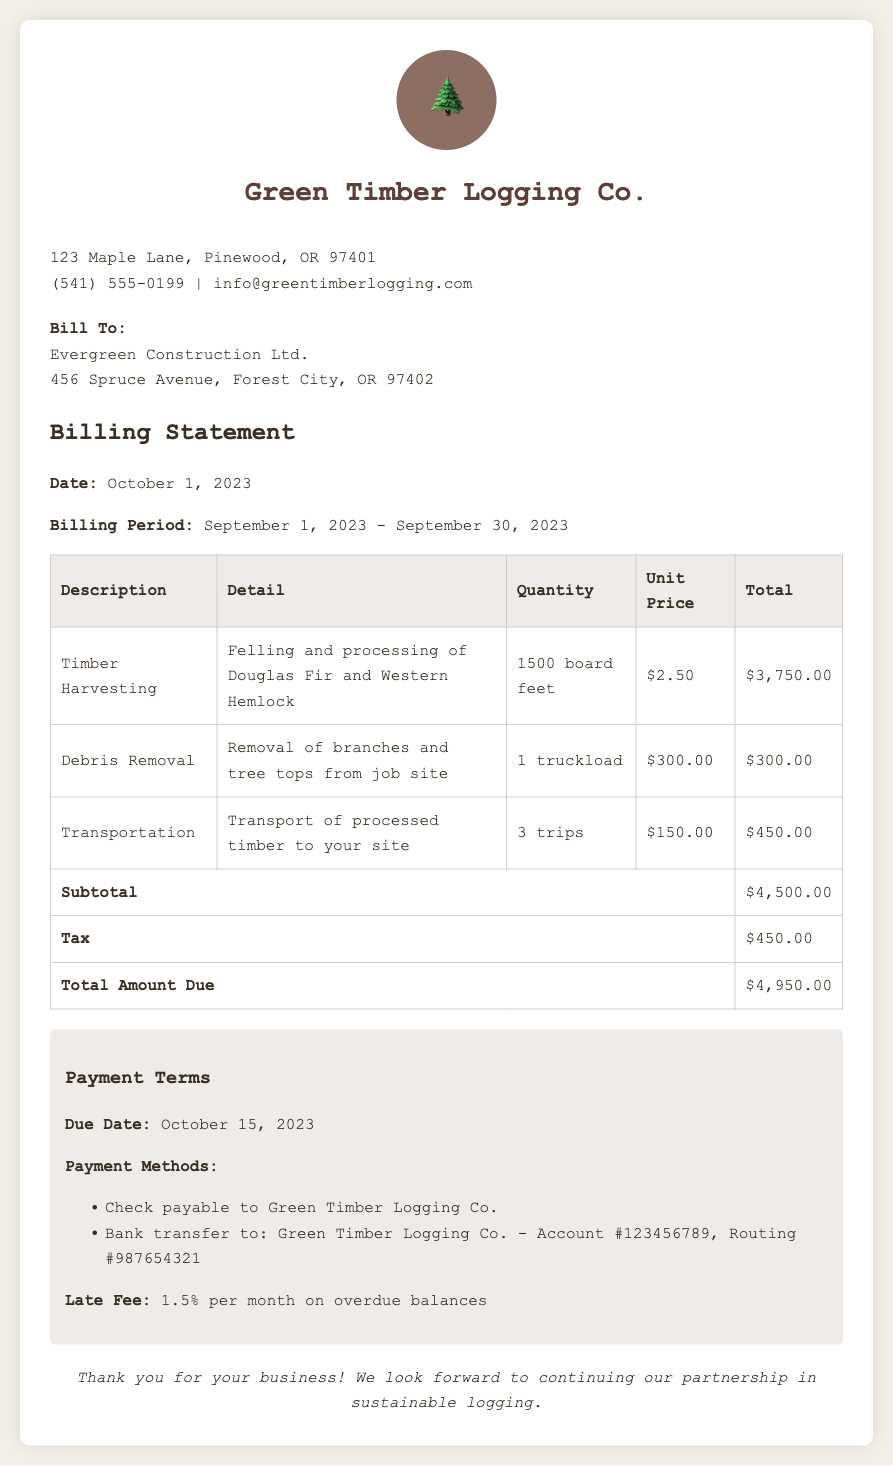What is the billing period? The billing period is detailed as the time frame between September 1, 2023, and September 30, 2023.
Answer: September 1, 2023 - September 30, 2023 What is the total amount due? The total amount due is specified at the end of the billing statement, after calculating the subtotal and adding tax.
Answer: $4,950.00 What service corresponds to 1500 board feet? The service that corresponds to 1500 board feet is Timber Harvesting, which involves felling and processing of specific types of trees.
Answer: Timber Harvesting What is the payment due date? The payment due date is indicated clearly, allowing clients to understand when payment is expected.
Answer: October 15, 2023 How much is the tax amount? The tax amount is listed separately in the billing statement and adds to the total due.
Answer: $450.00 What is the late fee percentage for overdue balances? The document specifies the late fee as a percentage of overdue balances as part of its payment terms.
Answer: 1.5% per month What is the contact number for Green Timber Logging Co.? The contact number is provided in the business information section of the document.
Answer: (541) 555-0199 What method is mentioned for bank transfers? The payment terms section outlines the method for bank transfers, indicating the relevant account and routing numbers.
Answer: Bank transfer to: Green Timber Logging Co. - Account #123456789, Routing #987654321 How many trips were made for transportation? The quantity of trips made for transportation is explicitly listed in the services breakdown.
Answer: 3 trips 